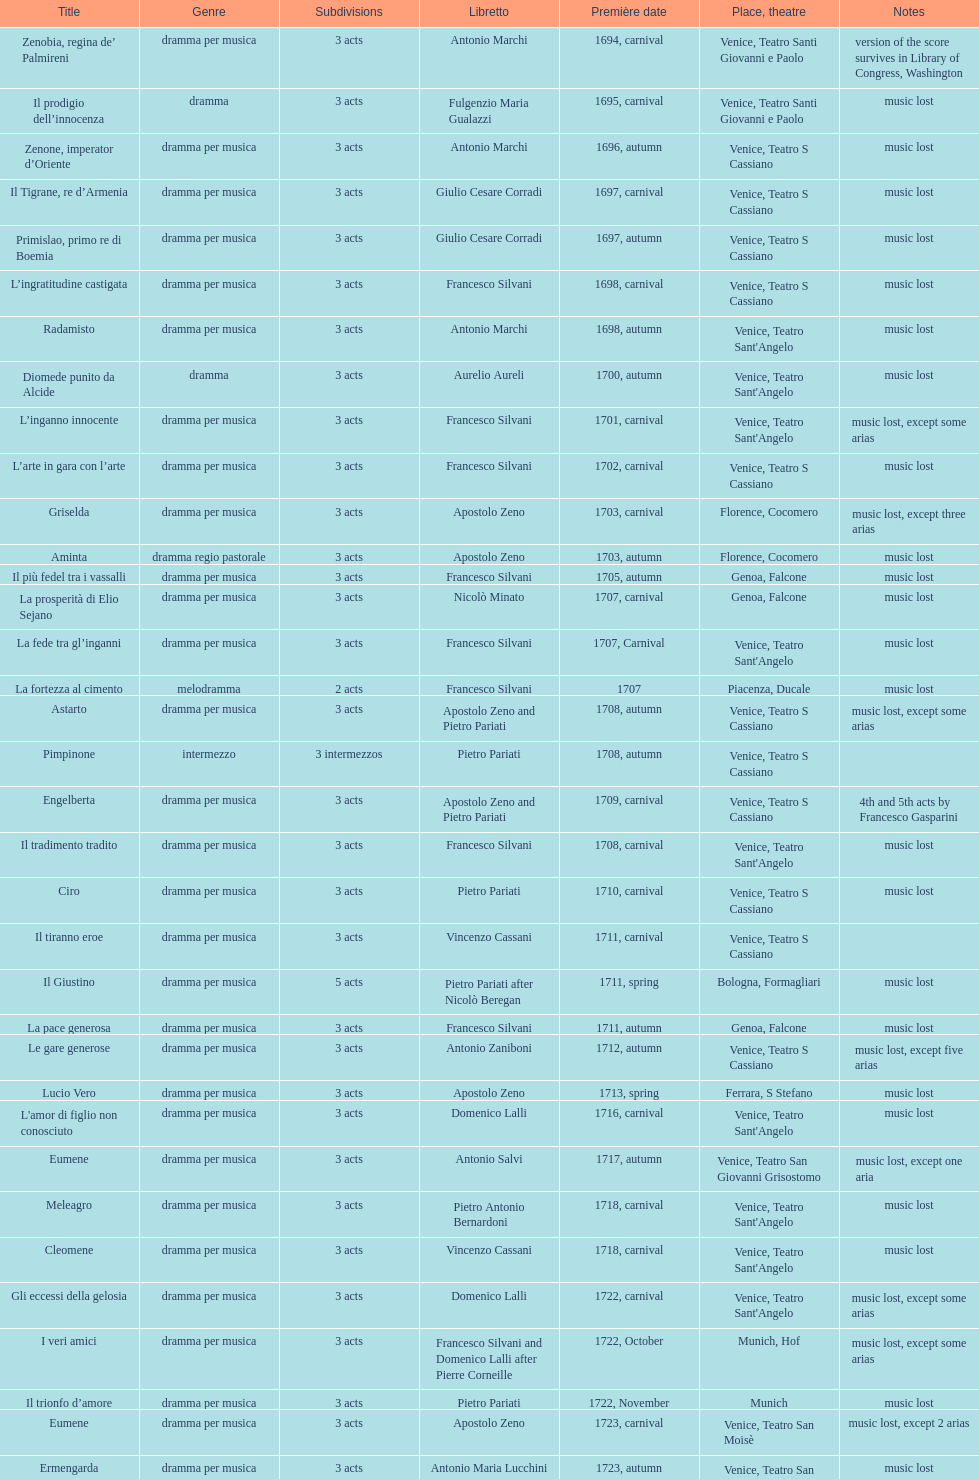L'inganno innocente first appeared in 170 Diomede punito da Alcide. 